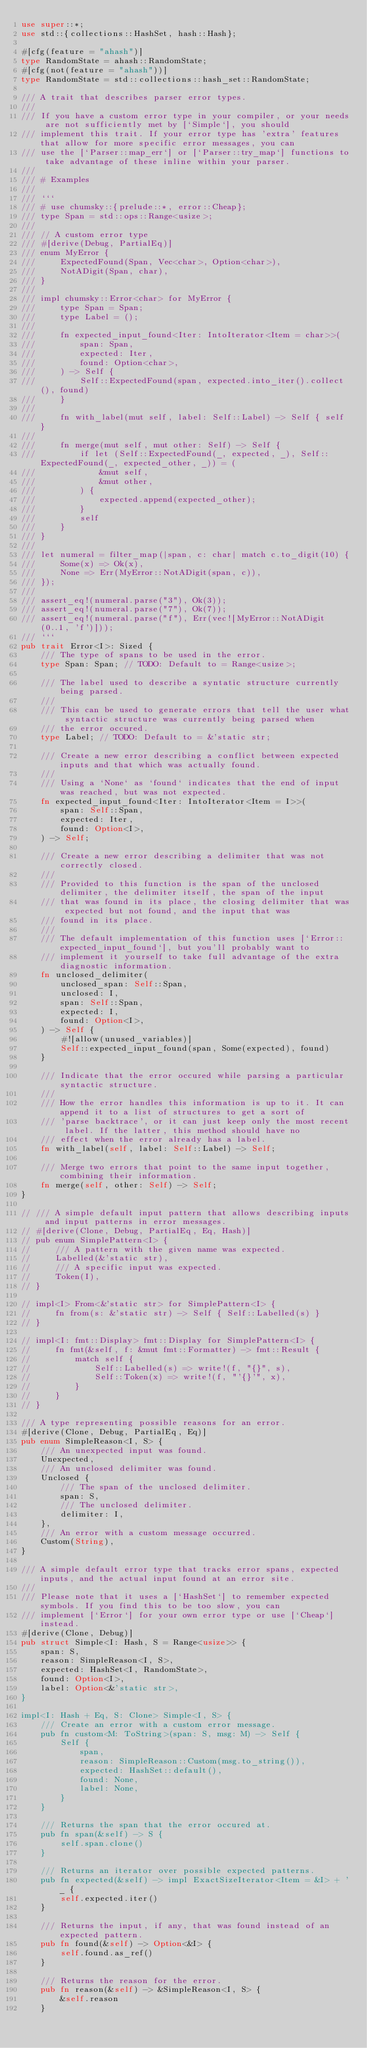Convert code to text. <code><loc_0><loc_0><loc_500><loc_500><_Rust_>use super::*;
use std::{collections::HashSet, hash::Hash};

#[cfg(feature = "ahash")]
type RandomState = ahash::RandomState;
#[cfg(not(feature = "ahash"))]
type RandomState = std::collections::hash_set::RandomState;

/// A trait that describes parser error types.
///
/// If you have a custom error type in your compiler, or your needs are not sufficiently met by [`Simple`], you should
/// implement this trait. If your error type has 'extra' features that allow for more specific error messages, you can
/// use the [`Parser::map_err`] or [`Parser::try_map`] functions to take advantage of these inline within your parser.
///
/// # Examples
///
/// ```
/// # use chumsky::{prelude::*, error::Cheap};
/// type Span = std::ops::Range<usize>;
///
/// // A custom error type
/// #[derive(Debug, PartialEq)]
/// enum MyError {
///     ExpectedFound(Span, Vec<char>, Option<char>),
///     NotADigit(Span, char),
/// }
///
/// impl chumsky::Error<char> for MyError {
///     type Span = Span;
///     type Label = ();
///
///     fn expected_input_found<Iter: IntoIterator<Item = char>>(
///         span: Span,
///         expected: Iter,
///         found: Option<char>,
///     ) -> Self {
///         Self::ExpectedFound(span, expected.into_iter().collect(), found)
///     }
///
///     fn with_label(mut self, label: Self::Label) -> Self { self }
///
///     fn merge(mut self, mut other: Self) -> Self {
///         if let (Self::ExpectedFound(_, expected, _), Self::ExpectedFound(_, expected_other, _)) = (
///             &mut self,
///             &mut other,
///         ) {
///             expected.append(expected_other);
///         }
///         self
///     }
/// }
///
/// let numeral = filter_map(|span, c: char| match c.to_digit(10) {
///     Some(x) => Ok(x),
///     None => Err(MyError::NotADigit(span, c)),
/// });
///
/// assert_eq!(numeral.parse("3"), Ok(3));
/// assert_eq!(numeral.parse("7"), Ok(7));
/// assert_eq!(numeral.parse("f"), Err(vec![MyError::NotADigit(0..1, 'f')]));
/// ```
pub trait Error<I>: Sized {
    /// The type of spans to be used in the error.
    type Span: Span; // TODO: Default to = Range<usize>;

    /// The label used to describe a syntatic structure currently being parsed.
    ///
    /// This can be used to generate errors that tell the user what syntactic structure was currently being parsed when
    /// the error occured.
    type Label; // TODO: Default to = &'static str;

    /// Create a new error describing a conflict between expected inputs and that which was actually found.
    ///
    /// Using a `None` as `found` indicates that the end of input was reached, but was not expected.
    fn expected_input_found<Iter: IntoIterator<Item = I>>(
        span: Self::Span,
        expected: Iter,
        found: Option<I>,
    ) -> Self;

    /// Create a new error describing a delimiter that was not correctly closed.
    ///
    /// Provided to this function is the span of the unclosed delimiter, the delimiter itself, the span of the input
    /// that was found in its place, the closing delimiter that was expected but not found, and the input that was
    /// found in its place.
    ///
    /// The default implementation of this function uses [`Error::expected_input_found`], but you'll probably want to
    /// implement it yourself to take full advantage of the extra diagnostic information.
    fn unclosed_delimiter(
        unclosed_span: Self::Span,
        unclosed: I,
        span: Self::Span,
        expected: I,
        found: Option<I>,
    ) -> Self {
        #![allow(unused_variables)]
        Self::expected_input_found(span, Some(expected), found)
    }

    /// Indicate that the error occured while parsing a particular syntactic structure.
    ///
    /// How the error handles this information is up to it. It can append it to a list of structures to get a sort of
    /// 'parse backtrace', or it can just keep only the most recent label. If the latter, this method should have no
    /// effect when the error already has a label.
    fn with_label(self, label: Self::Label) -> Self;

    /// Merge two errors that point to the same input together, combining their information.
    fn merge(self, other: Self) -> Self;
}

// /// A simple default input pattern that allows describing inputs and input patterns in error messages.
// #[derive(Clone, Debug, PartialEq, Eq, Hash)]
// pub enum SimplePattern<I> {
//     /// A pattern with the given name was expected.
//     Labelled(&'static str),
//     /// A specific input was expected.
//     Token(I),
// }

// impl<I> From<&'static str> for SimplePattern<I> {
//     fn from(s: &'static str) -> Self { Self::Labelled(s) }
// }

// impl<I: fmt::Display> fmt::Display for SimplePattern<I> {
//     fn fmt(&self, f: &mut fmt::Formatter) -> fmt::Result {
//         match self {
//             Self::Labelled(s) => write!(f, "{}", s),
//             Self::Token(x) => write!(f, "'{}'", x),
//         }
//     }
// }

/// A type representing possible reasons for an error.
#[derive(Clone, Debug, PartialEq, Eq)]
pub enum SimpleReason<I, S> {
    /// An unexpected input was found.
    Unexpected,
    /// An unclosed delimiter was found.
    Unclosed {
        /// The span of the unclosed delimiter.
        span: S,
        /// The unclosed delimiter.
        delimiter: I,
    },
    /// An error with a custom message occurred.
    Custom(String),
}

/// A simple default error type that tracks error spans, expected inputs, and the actual input found at an error site.
///
/// Please note that it uses a [`HashSet`] to remember expected symbols. If you find this to be too slow, you can
/// implement [`Error`] for your own error type or use [`Cheap`] instead.
#[derive(Clone, Debug)]
pub struct Simple<I: Hash, S = Range<usize>> {
    span: S,
    reason: SimpleReason<I, S>,
    expected: HashSet<I, RandomState>,
    found: Option<I>,
    label: Option<&'static str>,
}

impl<I: Hash + Eq, S: Clone> Simple<I, S> {
    /// Create an error with a custom error message.
    pub fn custom<M: ToString>(span: S, msg: M) -> Self {
        Self {
            span,
            reason: SimpleReason::Custom(msg.to_string()),
            expected: HashSet::default(),
            found: None,
            label: None,
        }
    }

    /// Returns the span that the error occured at.
    pub fn span(&self) -> S {
        self.span.clone()
    }

    /// Returns an iterator over possible expected patterns.
    pub fn expected(&self) -> impl ExactSizeIterator<Item = &I> + '_ {
        self.expected.iter()
    }

    /// Returns the input, if any, that was found instead of an expected pattern.
    pub fn found(&self) -> Option<&I> {
        self.found.as_ref()
    }

    /// Returns the reason for the error.
    pub fn reason(&self) -> &SimpleReason<I, S> {
        &self.reason
    }
</code> 